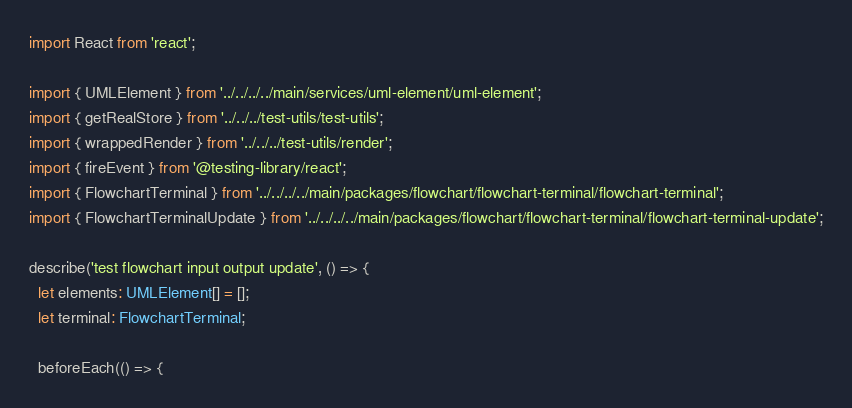<code> <loc_0><loc_0><loc_500><loc_500><_TypeScript_>import React from 'react';

import { UMLElement } from '../../../../main/services/uml-element/uml-element';
import { getRealStore } from '../../../test-utils/test-utils';
import { wrappedRender } from '../../../test-utils/render';
import { fireEvent } from '@testing-library/react';
import { FlowchartTerminal } from '../../../../main/packages/flowchart/flowchart-terminal/flowchart-terminal';
import { FlowchartTerminalUpdate } from '../../../../main/packages/flowchart/flowchart-terminal/flowchart-terminal-update';

describe('test flowchart input output update', () => {
  let elements: UMLElement[] = [];
  let terminal: FlowchartTerminal;

  beforeEach(() => {</code> 